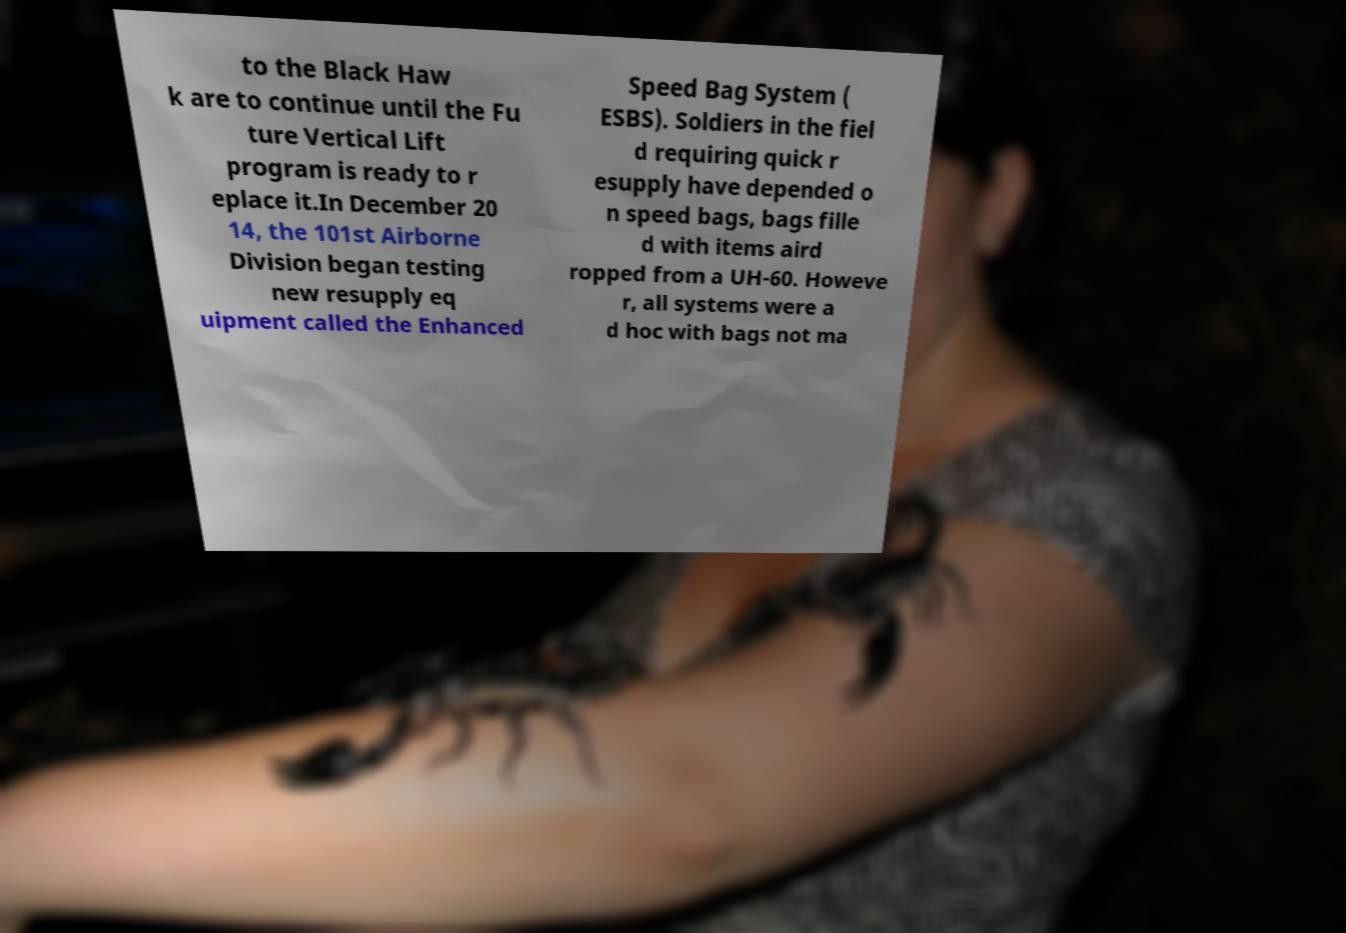What messages or text are displayed in this image? I need them in a readable, typed format. to the Black Haw k are to continue until the Fu ture Vertical Lift program is ready to r eplace it.In December 20 14, the 101st Airborne Division began testing new resupply eq uipment called the Enhanced Speed Bag System ( ESBS). Soldiers in the fiel d requiring quick r esupply have depended o n speed bags, bags fille d with items aird ropped from a UH-60. Howeve r, all systems were a d hoc with bags not ma 